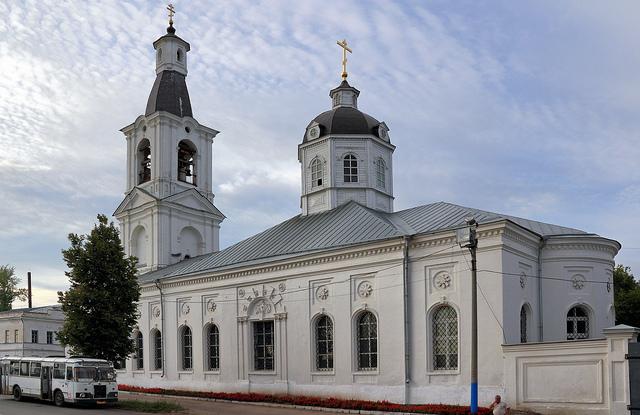Is this a church?
Be succinct. Yes. What color is the building?
Keep it brief. White. Is this someone's home?
Quick response, please. No. 